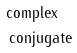Convert formula to latex. <formula><loc_0><loc_0><loc_500><loc_500>& \text {complex} \\ & \, \text {conjugate}</formula> 